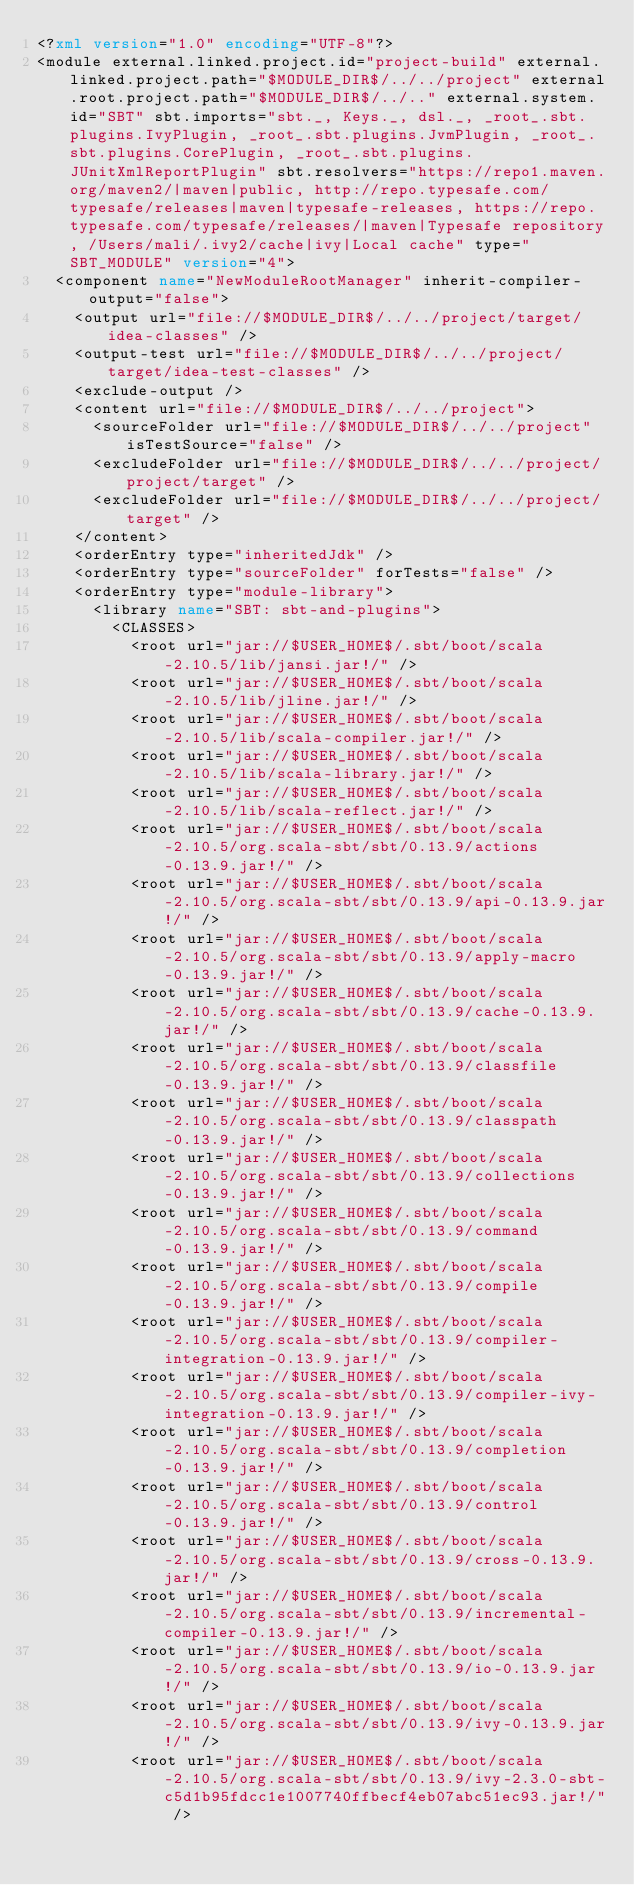<code> <loc_0><loc_0><loc_500><loc_500><_XML_><?xml version="1.0" encoding="UTF-8"?>
<module external.linked.project.id="project-build" external.linked.project.path="$MODULE_DIR$/../../project" external.root.project.path="$MODULE_DIR$/../.." external.system.id="SBT" sbt.imports="sbt._, Keys._, dsl._, _root_.sbt.plugins.IvyPlugin, _root_.sbt.plugins.JvmPlugin, _root_.sbt.plugins.CorePlugin, _root_.sbt.plugins.JUnitXmlReportPlugin" sbt.resolvers="https://repo1.maven.org/maven2/|maven|public, http://repo.typesafe.com/typesafe/releases|maven|typesafe-releases, https://repo.typesafe.com/typesafe/releases/|maven|Typesafe repository, /Users/mali/.ivy2/cache|ivy|Local cache" type="SBT_MODULE" version="4">
  <component name="NewModuleRootManager" inherit-compiler-output="false">
    <output url="file://$MODULE_DIR$/../../project/target/idea-classes" />
    <output-test url="file://$MODULE_DIR$/../../project/target/idea-test-classes" />
    <exclude-output />
    <content url="file://$MODULE_DIR$/../../project">
      <sourceFolder url="file://$MODULE_DIR$/../../project" isTestSource="false" />
      <excludeFolder url="file://$MODULE_DIR$/../../project/project/target" />
      <excludeFolder url="file://$MODULE_DIR$/../../project/target" />
    </content>
    <orderEntry type="inheritedJdk" />
    <orderEntry type="sourceFolder" forTests="false" />
    <orderEntry type="module-library">
      <library name="SBT: sbt-and-plugins">
        <CLASSES>
          <root url="jar://$USER_HOME$/.sbt/boot/scala-2.10.5/lib/jansi.jar!/" />
          <root url="jar://$USER_HOME$/.sbt/boot/scala-2.10.5/lib/jline.jar!/" />
          <root url="jar://$USER_HOME$/.sbt/boot/scala-2.10.5/lib/scala-compiler.jar!/" />
          <root url="jar://$USER_HOME$/.sbt/boot/scala-2.10.5/lib/scala-library.jar!/" />
          <root url="jar://$USER_HOME$/.sbt/boot/scala-2.10.5/lib/scala-reflect.jar!/" />
          <root url="jar://$USER_HOME$/.sbt/boot/scala-2.10.5/org.scala-sbt/sbt/0.13.9/actions-0.13.9.jar!/" />
          <root url="jar://$USER_HOME$/.sbt/boot/scala-2.10.5/org.scala-sbt/sbt/0.13.9/api-0.13.9.jar!/" />
          <root url="jar://$USER_HOME$/.sbt/boot/scala-2.10.5/org.scala-sbt/sbt/0.13.9/apply-macro-0.13.9.jar!/" />
          <root url="jar://$USER_HOME$/.sbt/boot/scala-2.10.5/org.scala-sbt/sbt/0.13.9/cache-0.13.9.jar!/" />
          <root url="jar://$USER_HOME$/.sbt/boot/scala-2.10.5/org.scala-sbt/sbt/0.13.9/classfile-0.13.9.jar!/" />
          <root url="jar://$USER_HOME$/.sbt/boot/scala-2.10.5/org.scala-sbt/sbt/0.13.9/classpath-0.13.9.jar!/" />
          <root url="jar://$USER_HOME$/.sbt/boot/scala-2.10.5/org.scala-sbt/sbt/0.13.9/collections-0.13.9.jar!/" />
          <root url="jar://$USER_HOME$/.sbt/boot/scala-2.10.5/org.scala-sbt/sbt/0.13.9/command-0.13.9.jar!/" />
          <root url="jar://$USER_HOME$/.sbt/boot/scala-2.10.5/org.scala-sbt/sbt/0.13.9/compile-0.13.9.jar!/" />
          <root url="jar://$USER_HOME$/.sbt/boot/scala-2.10.5/org.scala-sbt/sbt/0.13.9/compiler-integration-0.13.9.jar!/" />
          <root url="jar://$USER_HOME$/.sbt/boot/scala-2.10.5/org.scala-sbt/sbt/0.13.9/compiler-ivy-integration-0.13.9.jar!/" />
          <root url="jar://$USER_HOME$/.sbt/boot/scala-2.10.5/org.scala-sbt/sbt/0.13.9/completion-0.13.9.jar!/" />
          <root url="jar://$USER_HOME$/.sbt/boot/scala-2.10.5/org.scala-sbt/sbt/0.13.9/control-0.13.9.jar!/" />
          <root url="jar://$USER_HOME$/.sbt/boot/scala-2.10.5/org.scala-sbt/sbt/0.13.9/cross-0.13.9.jar!/" />
          <root url="jar://$USER_HOME$/.sbt/boot/scala-2.10.5/org.scala-sbt/sbt/0.13.9/incremental-compiler-0.13.9.jar!/" />
          <root url="jar://$USER_HOME$/.sbt/boot/scala-2.10.5/org.scala-sbt/sbt/0.13.9/io-0.13.9.jar!/" />
          <root url="jar://$USER_HOME$/.sbt/boot/scala-2.10.5/org.scala-sbt/sbt/0.13.9/ivy-0.13.9.jar!/" />
          <root url="jar://$USER_HOME$/.sbt/boot/scala-2.10.5/org.scala-sbt/sbt/0.13.9/ivy-2.3.0-sbt-c5d1b95fdcc1e1007740ffbecf4eb07abc51ec93.jar!/" /></code> 